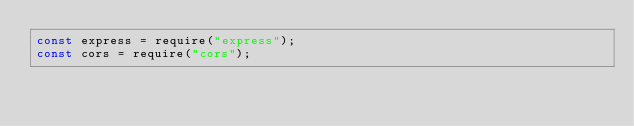Convert code to text. <code><loc_0><loc_0><loc_500><loc_500><_JavaScript_>const express = require("express");
const cors = require("cors");
</code> 